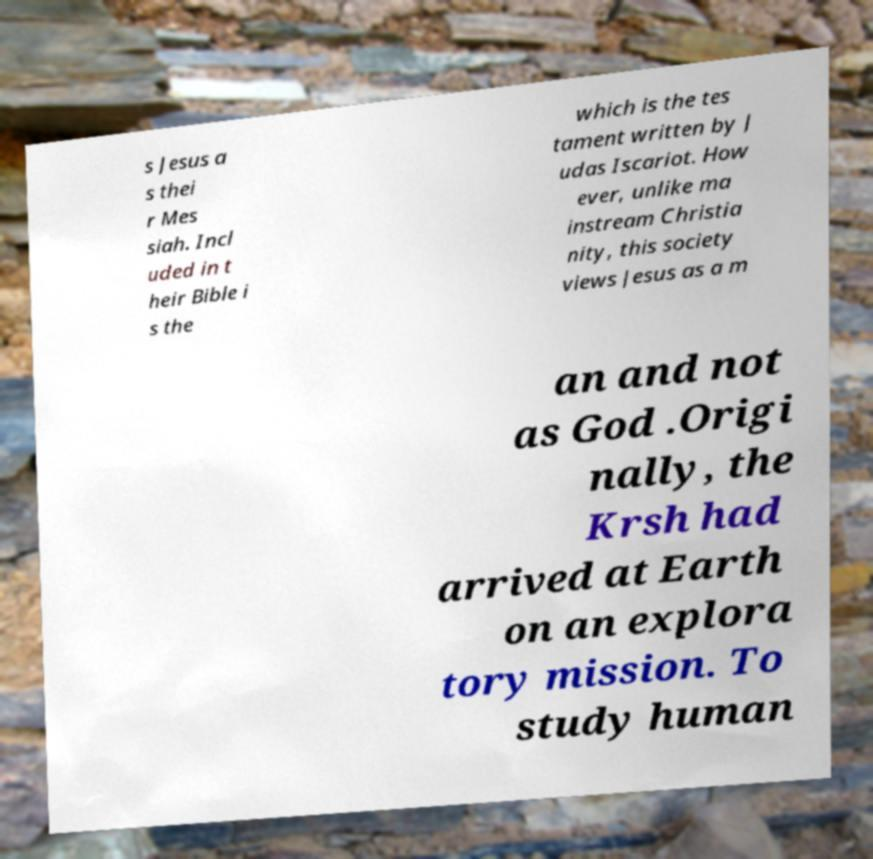Please identify and transcribe the text found in this image. s Jesus a s thei r Mes siah. Incl uded in t heir Bible i s the which is the tes tament written by J udas Iscariot. How ever, unlike ma instream Christia nity, this society views Jesus as a m an and not as God .Origi nally, the Krsh had arrived at Earth on an explora tory mission. To study human 